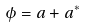Convert formula to latex. <formula><loc_0><loc_0><loc_500><loc_500>\phi = a + a ^ { \ast }</formula> 